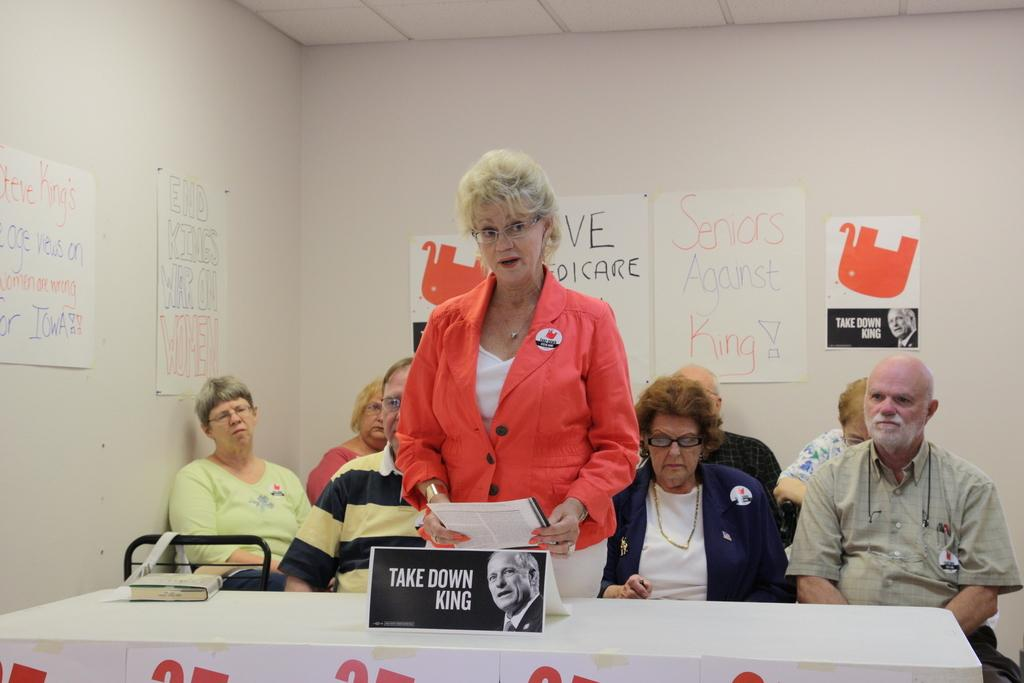How many people are in the image? There are people in the image, but the exact number is not specified. Can you describe the positions of the people in the image? A woman is standing among the people, and the rest of the people are sitting. What is on the table in the image? There is a board and a book on the table in the image. Are there any structural elements visible on the walls in the image? Yes, there are posts on the walls in the image. What type of bun is being served during the feast in the image? There is no feast or bun present in the image. How does the rainstorm affect the people in the image? There is no rainstorm or indication of weather in the image. 